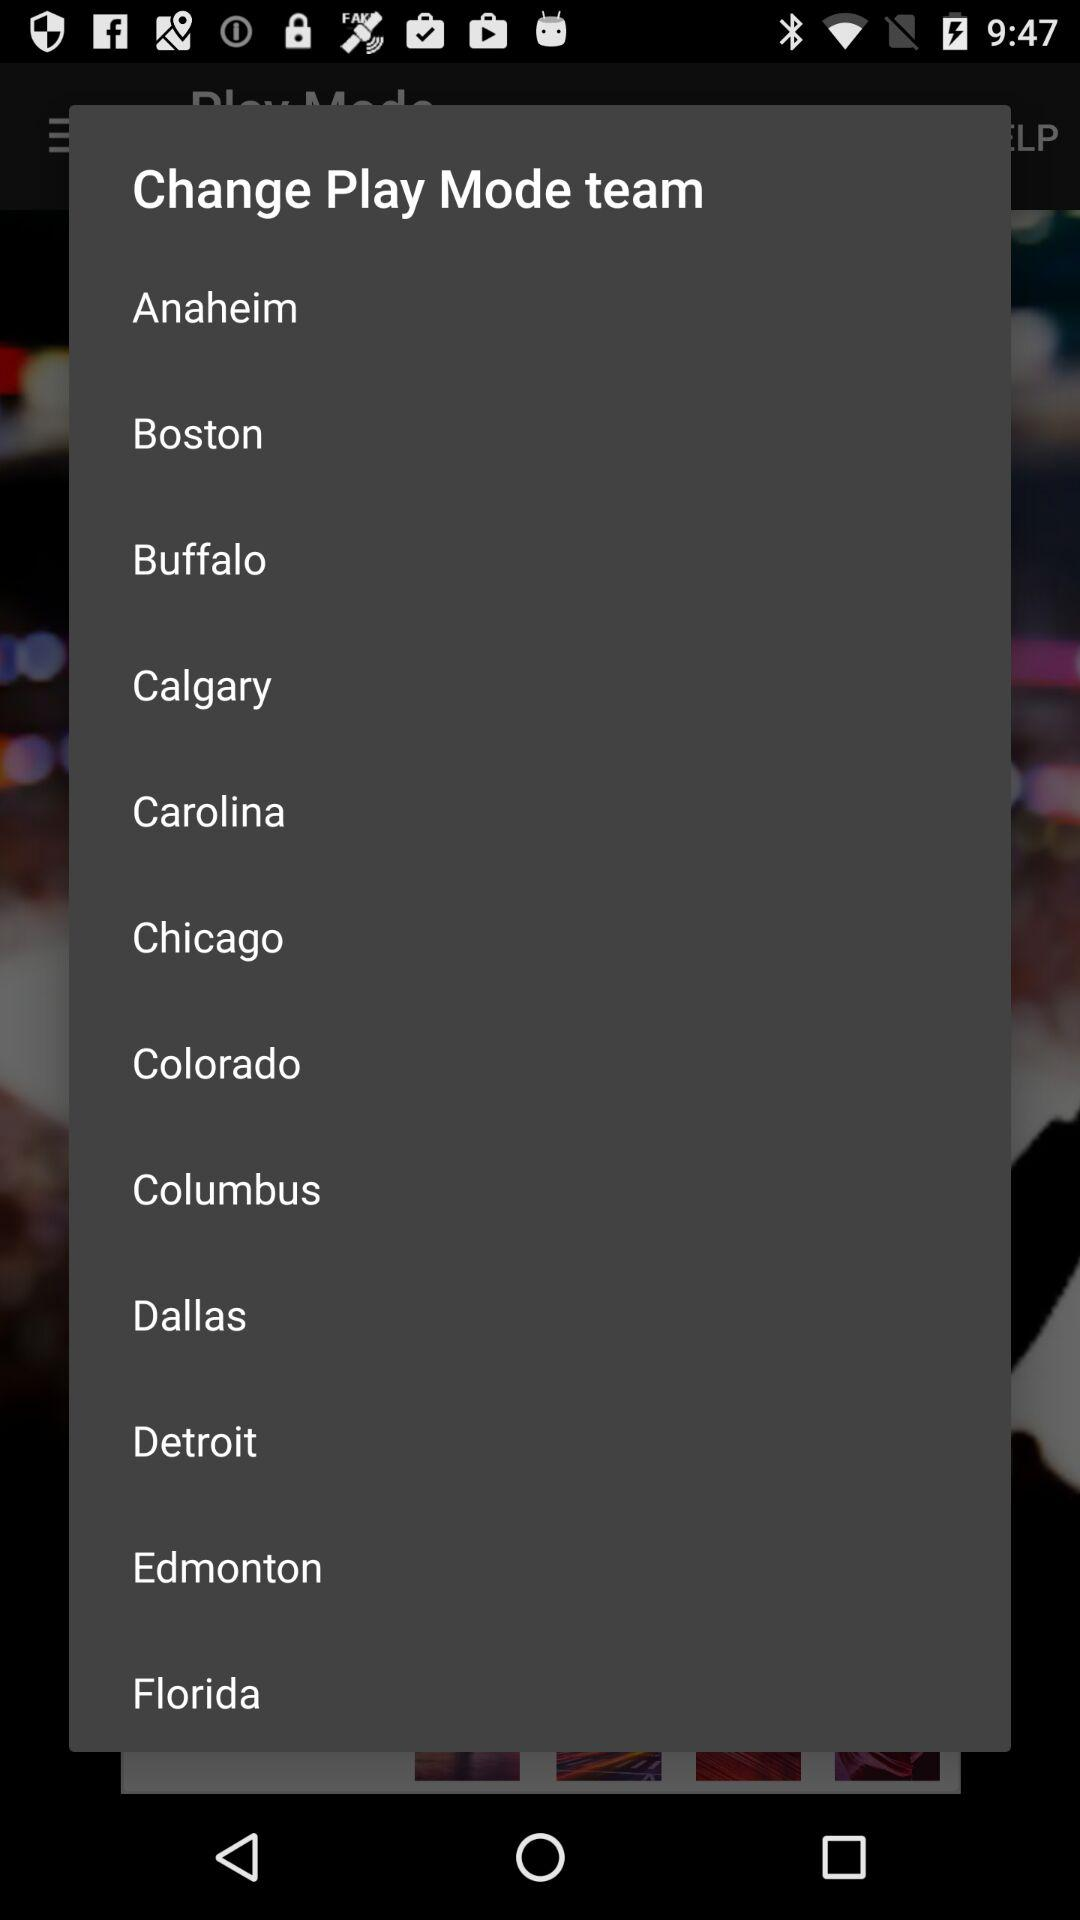What are the different available play mode team options? The different available play mode team options are "Anaheim", "Boston", "Buffalo", "Calgary", "Carolina", "Chicago", "Colorado", "Columbus", "Dallas", "Detroit", "Edmonton" and "Florida". 